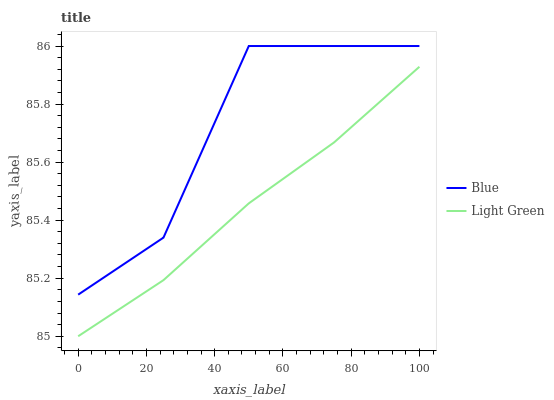Does Light Green have the minimum area under the curve?
Answer yes or no. Yes. Does Blue have the maximum area under the curve?
Answer yes or no. Yes. Does Light Green have the maximum area under the curve?
Answer yes or no. No. Is Light Green the smoothest?
Answer yes or no. Yes. Is Blue the roughest?
Answer yes or no. Yes. Is Light Green the roughest?
Answer yes or no. No. Does Light Green have the lowest value?
Answer yes or no. Yes. Does Blue have the highest value?
Answer yes or no. Yes. Does Light Green have the highest value?
Answer yes or no. No. Is Light Green less than Blue?
Answer yes or no. Yes. Is Blue greater than Light Green?
Answer yes or no. Yes. Does Light Green intersect Blue?
Answer yes or no. No. 